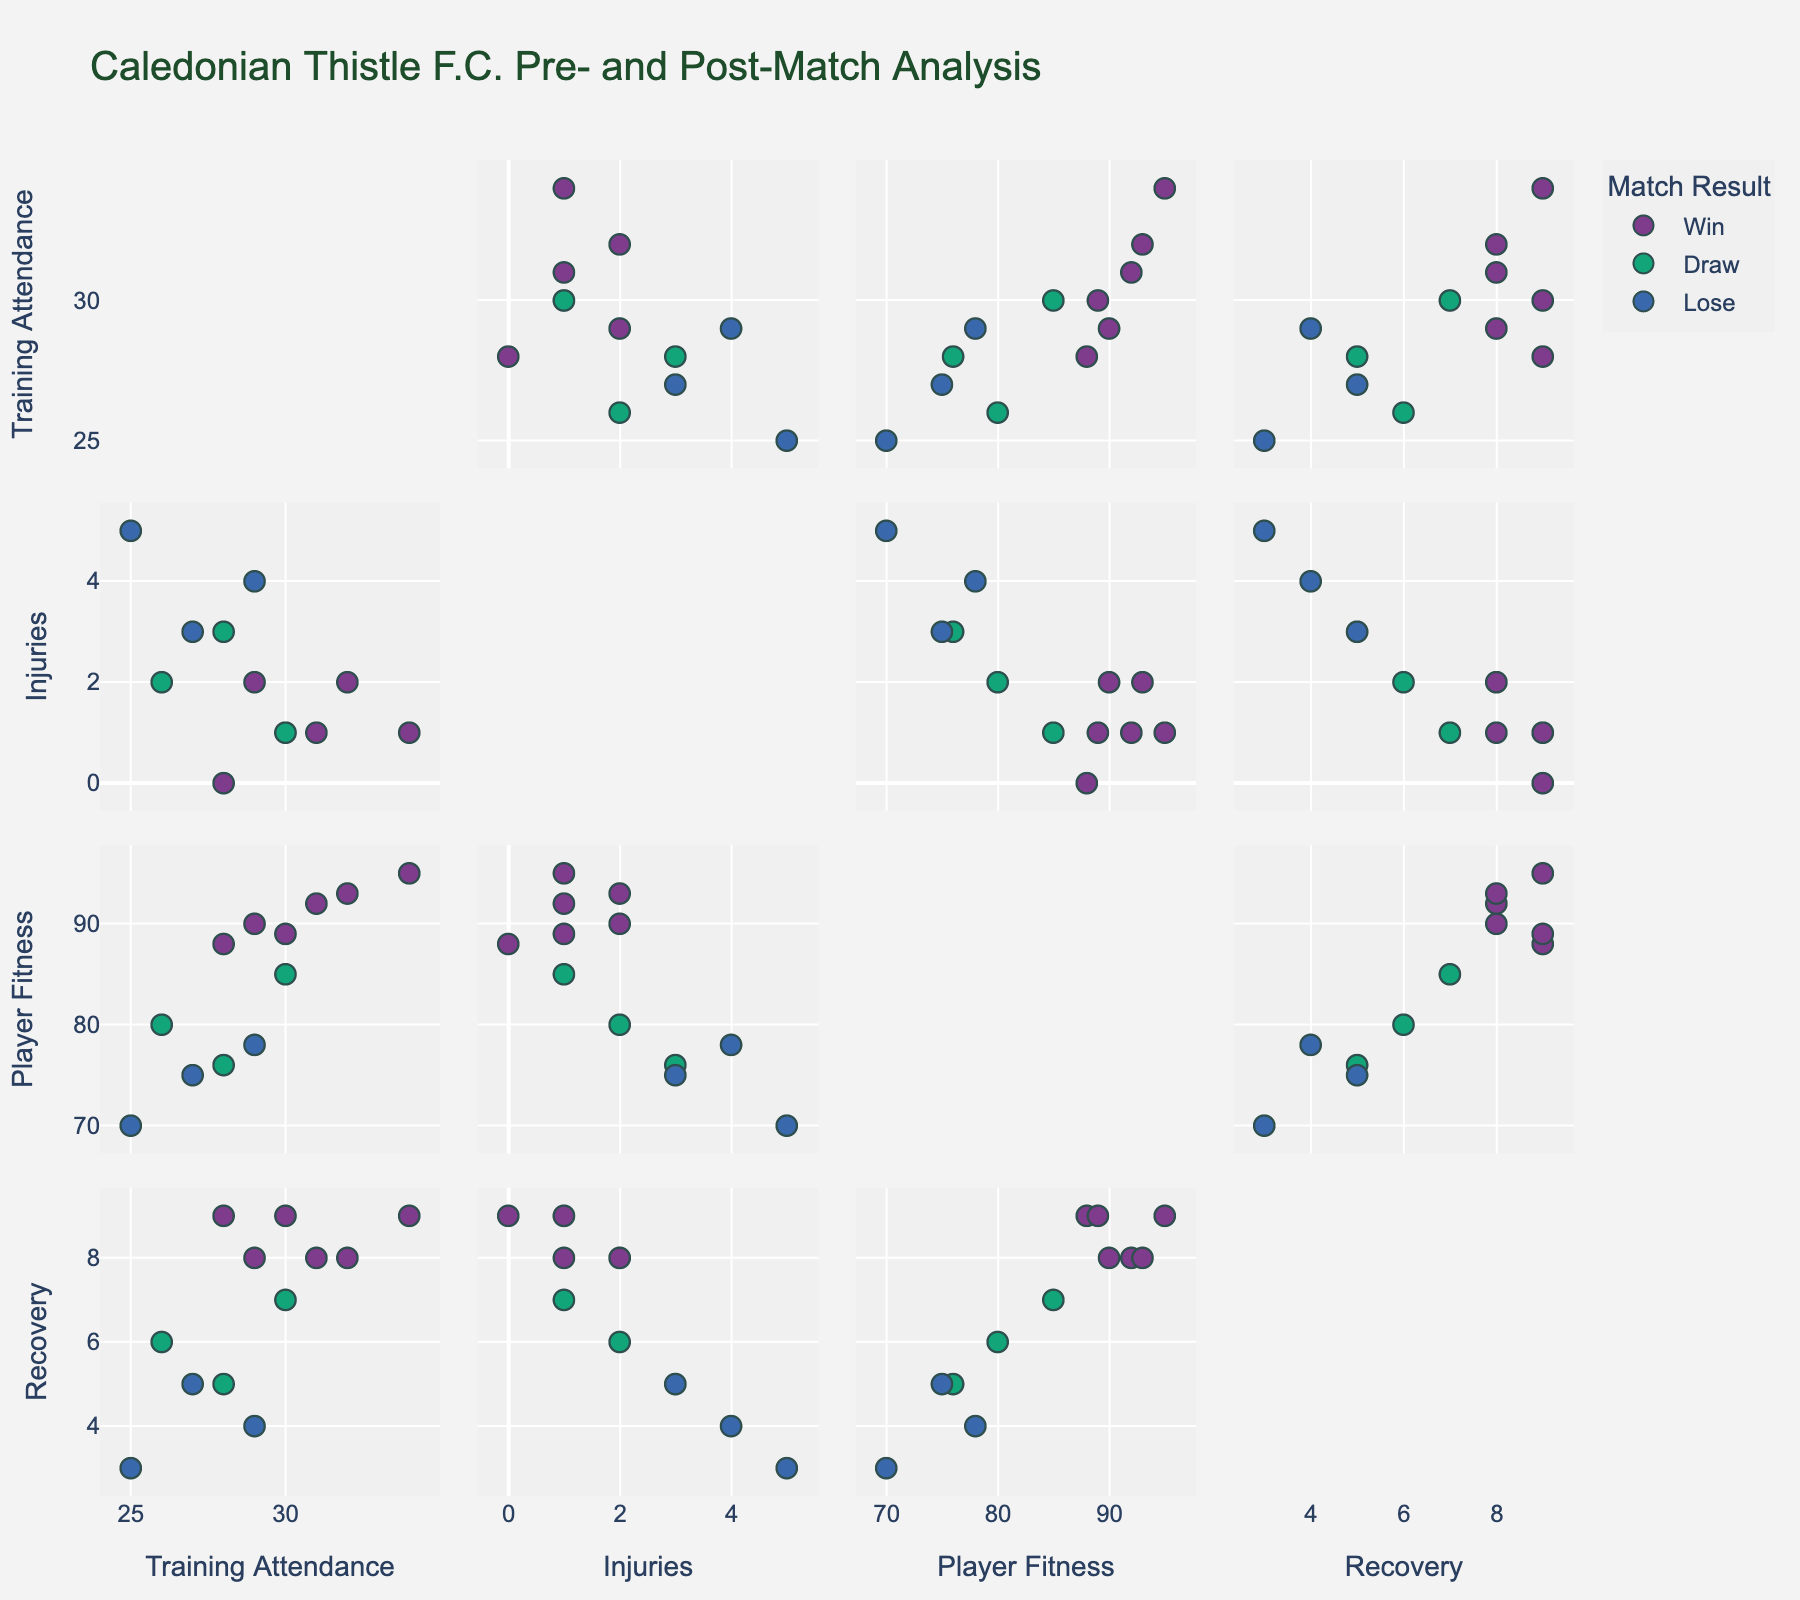what are the variables plotted in the scatter plot matrix? The scatter plot matrix includes the following variables: 'Training Attendance', 'Injuries', 'Player Fitness', and 'Post-Match Recovery'.
Answer: Training Attendance, Injuries, Player Fitness, Post-Match Recovery How many color categories represent match results? The scatter plot matrix uses different colors to represent various match results, and we can see there are three different colors, which correspond to Win, Draw, and Lose.
Answer: 3 Considering all the data points, what is the highest value for player fitness? By observing the scatter plot matrix, we can identify the maximum value on the axis representing Player Fitness, which is 95.
Answer: 95 How many data points indicate a 'Draw' in match results? By counting the data points colored the same and representing the match result as 'Draw', we find there are 3 such data points.
Answer: 3 What can be said about the relationship between training attendance and player fitness for matches that were won? Observing the scatter plot matrix for data points that signify wins, we see that higher training attendance generally correlates with higher player fitness.
Answer: Higher training attendance tends to correlate with higher player fitness in won matches Which category had the worst post-match recovery and what was the corresponding match result? The lowest post-match recovery value in the scatter plot matrix is 3, which corresponds to a match result of 'Lose.'
Answer: Lose Is there a clear relationship between the number of injuries and the match result? By examining the scatter plots, no clear or consistent pattern emerges directly linking the number of injuries to a specific match result across the various data points.
Answer: No clear relationship Which set of variables seem to have the most positive correlation in the scatter plots? The scatter plots indicate that Training Attendance and Player Fitness show a positive correlation, meaning as training attendance increases, player fitness tends to increase.
Answer: Training Attendance and Player Fitness What is the range of post-match recovery times for the 'Win' match result category? To find the range, we look at the highest and lowest post-match recovery values corresponding to the Win category in the scatter plot matrix, which are 9 and 8 respectively, giving a range of 9 - 8 = 1.
Answer: 1 How does increased Training Attendance affect Post-Match Recovery? Observing the scatter plots of Training Attendance vs. Post-Match Recovery, we see a general trend that increased training attendance correlates with better post-match recovery.
Answer: Positive correlation 